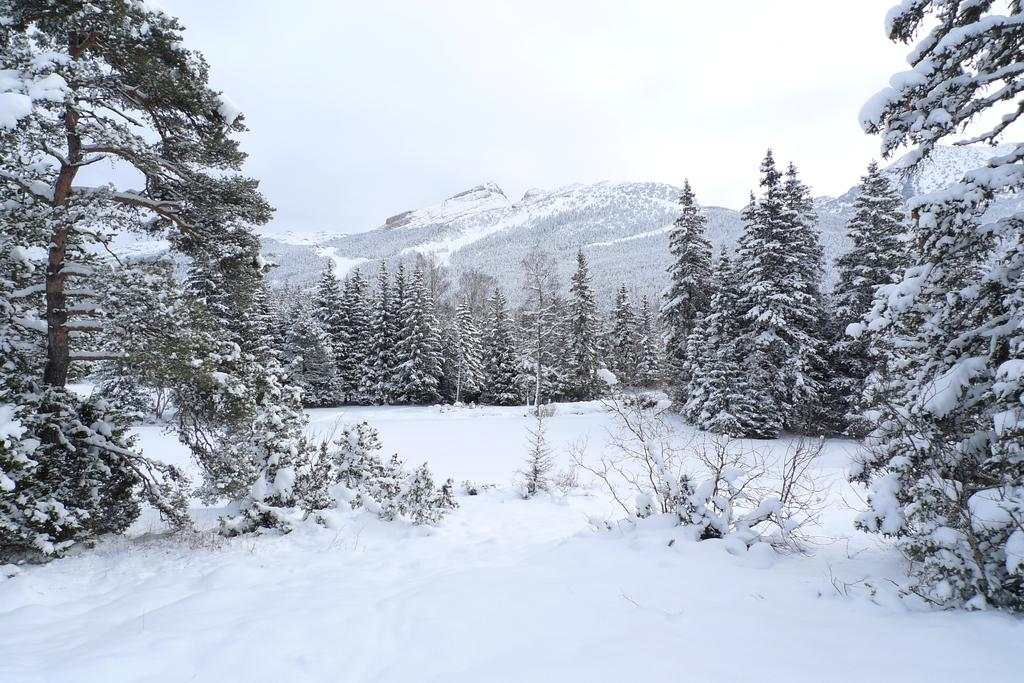What is the condition of the land in the image? The land is covered with snow. What else is covered with snow in the image? Trees are covered with snow. What can be seen in the background of the image? There is a mountain in the background of the image. What type of lock can be seen on the trees in the image? There are no locks present on the trees in the image; they are covered with snow. 